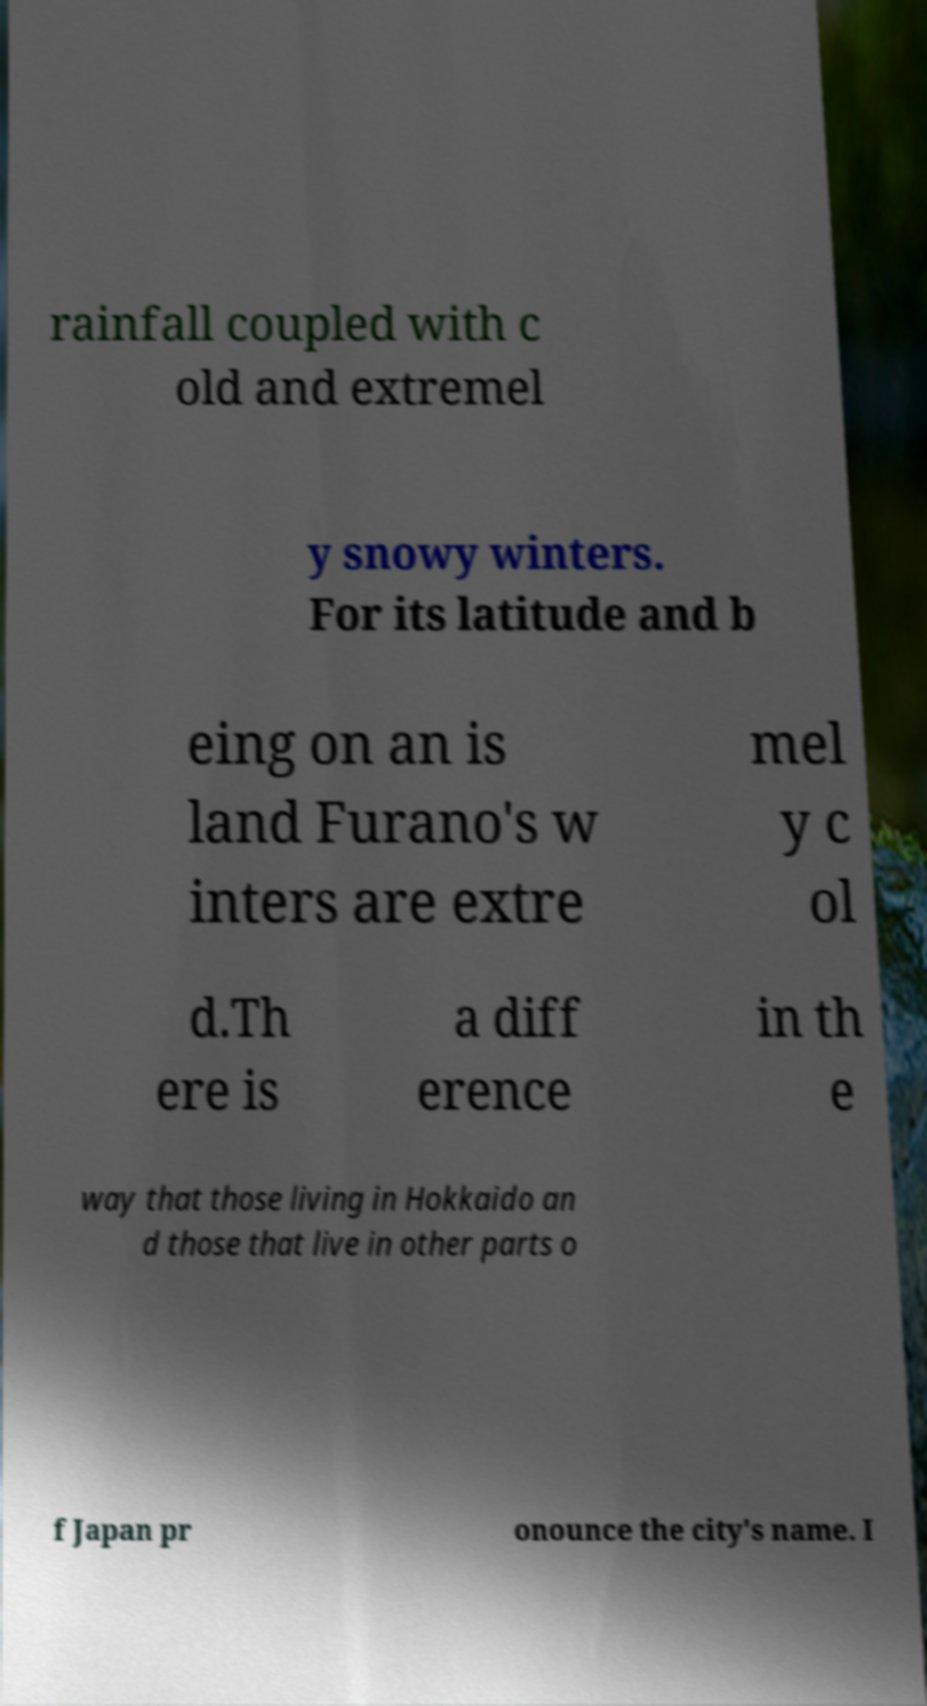There's text embedded in this image that I need extracted. Can you transcribe it verbatim? rainfall coupled with c old and extremel y snowy winters. For its latitude and b eing on an is land Furano's w inters are extre mel y c ol d.Th ere is a diff erence in th e way that those living in Hokkaido an d those that live in other parts o f Japan pr onounce the city's name. I 